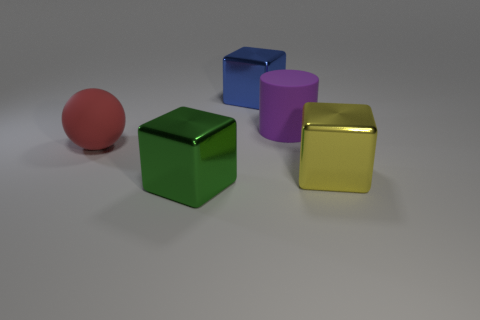What number of other objects are there of the same material as the large ball?
Ensure brevity in your answer.  1. There is a large shiny thing to the left of the large blue block; is it the same shape as the object that is to the left of the big green metallic object?
Your response must be concise. No. What number of other objects are the same color as the large matte ball?
Provide a short and direct response. 0. Is the object right of the big purple object made of the same material as the red object that is behind the big green metal cube?
Your answer should be compact. No. Are there an equal number of blue metal things behind the large purple matte cylinder and yellow objects on the left side of the yellow block?
Ensure brevity in your answer.  No. There is a big object that is to the left of the large green metal object; what is it made of?
Offer a very short reply. Rubber. Is there any other thing that is the same size as the red rubber thing?
Provide a succinct answer. Yes. Are there fewer big green things than large yellow rubber blocks?
Give a very brief answer. No. What shape is the big thing that is both to the left of the large purple thing and in front of the red rubber object?
Your response must be concise. Cube. How many big blocks are there?
Your response must be concise. 3. 